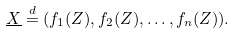<formula> <loc_0><loc_0><loc_500><loc_500>\underline { X } \stackrel { d } { = } ( f _ { 1 } ( Z ) , f _ { 2 } ( Z ) , \dots , f _ { n } ( Z ) ) .</formula> 